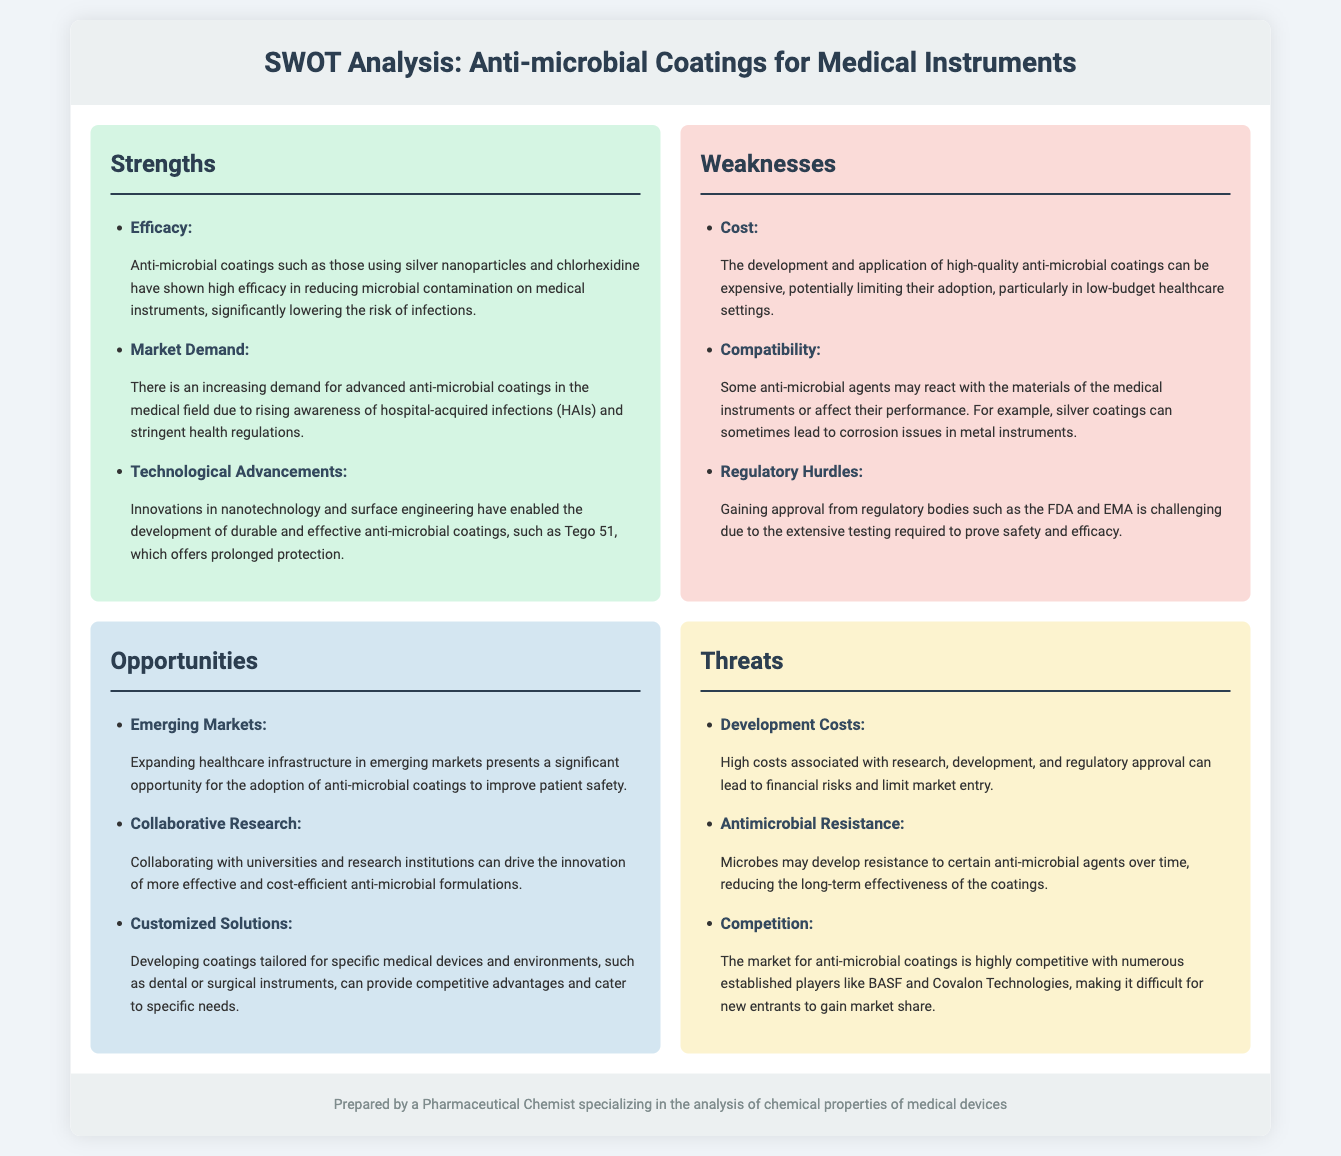What is a key strength of anti-microbial coatings? The document highlights the efficacy of anti-microbial coatings in reducing microbial contamination as a key strength.
Answer: Efficacy What emerging market opportunity is mentioned? The analysis points to expanding healthcare infrastructure in emerging markets as a significant opportunity.
Answer: Emerging Markets What is a major threat related to development? High costs associated with research and development are identified as a significant threat.
Answer: Development Costs Which established player is mentioned in competition? The document lists BASF as one of the competitive players in the anti-microbial coatings market.
Answer: BASF What is a weakness mentioned regarding compatibility? The document states that some anti-microbial agents may react with the materials of the medical instruments.
Answer: Compatibility What aspect of anti-microbial formulations can be improved through collaboration? The document suggests that collaborating with universities and research institutions can drive innovation in anti-microbial formulations.
Answer: Collaborative Research Which anti-microbial agent is specifically mentioned for its efficacy? Silver nanoparticles are highlighted as an effective component of anti-microbial coatings.
Answer: Silver nanoparticles What does the document mention as a concern regarding microbial resistance? It mentions that microbes may develop resistance to certain anti-microbial agents over time.
Answer: Antimicrobial Resistance 